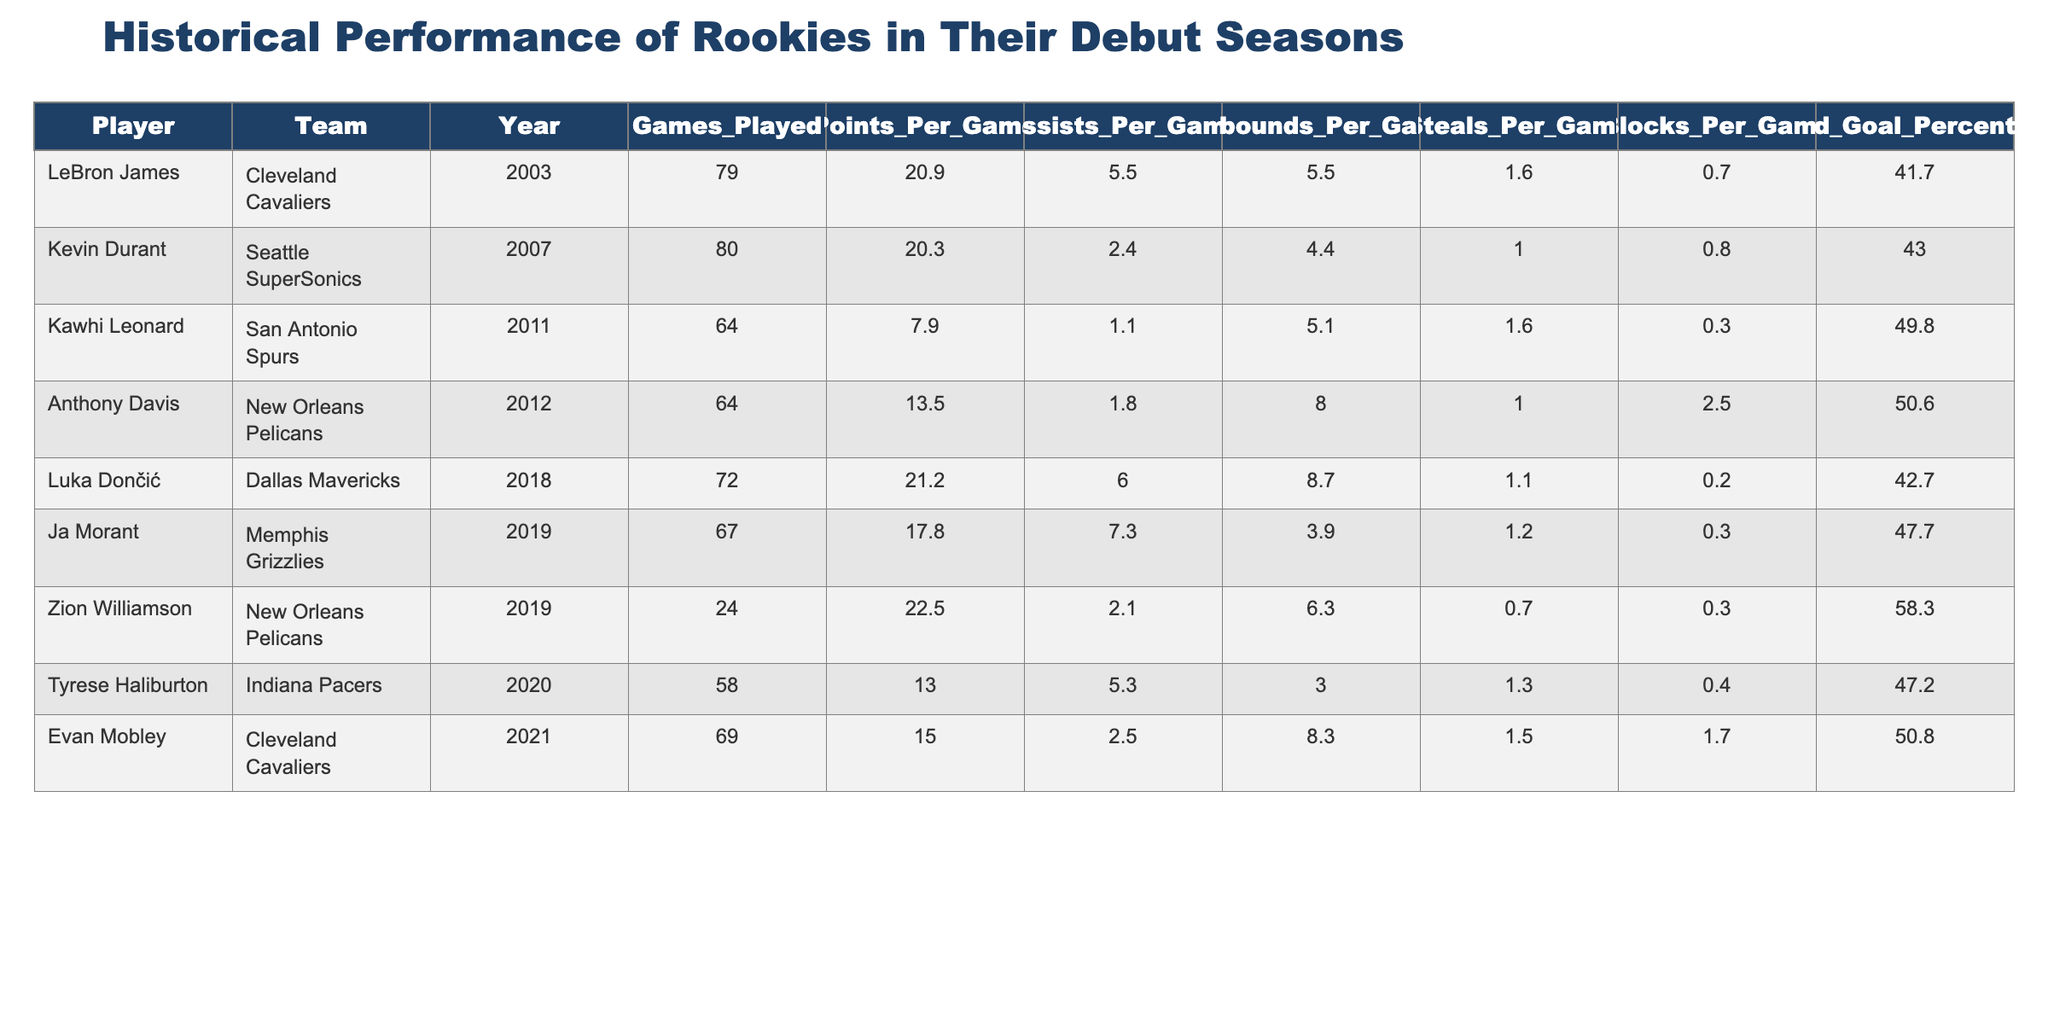What was Zion Williamson's points per game in his rookie season? The table shows that Zion Williamson had 22.5 points per game.
Answer: 22.5 Which rookie had the highest field goal percentage? By looking at the "Field Goal Percentage" column, Kawhi Leonard had the highest percentage at 49.8.
Answer: 49.8 What are the average assists per game for the rookies listed? The assists per game are 5.5, 2.4, 1.1, 1.8, 6.0, 7.3, 2.1, 5.3, 2.5. Adding these gives 28.5; dividing by 9 gives an average of 3.17.
Answer: 3.17 Did Anthony Davis have more rebounds per game than Luka Dončić in their rookie seasons? From the table, Anthony Davis had 8.0 rebounds per game while Luka Dončić had 8.7 rebounds. Since 8.0 is less than 8.7, the answer is no.
Answer: No Which player had the lowest number of games played in their debut season? The number of games played by each player are 79, 80, 64, 64, 72, 67, 24, 58, 69. The minimum is 24 games played by Zion Williamson.
Answer: 24 